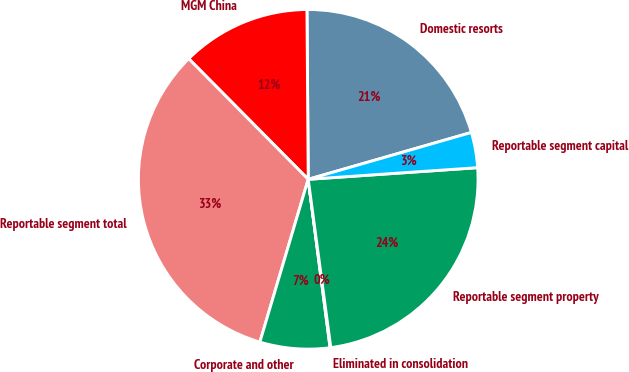<chart> <loc_0><loc_0><loc_500><loc_500><pie_chart><fcel>Domestic resorts<fcel>MGM China<fcel>Reportable segment total<fcel>Corporate and other<fcel>Eliminated in consolidation<fcel>Reportable segment property<fcel>Reportable segment capital<nl><fcel>20.67%<fcel>12.31%<fcel>32.98%<fcel>6.65%<fcel>0.07%<fcel>23.97%<fcel>3.36%<nl></chart> 